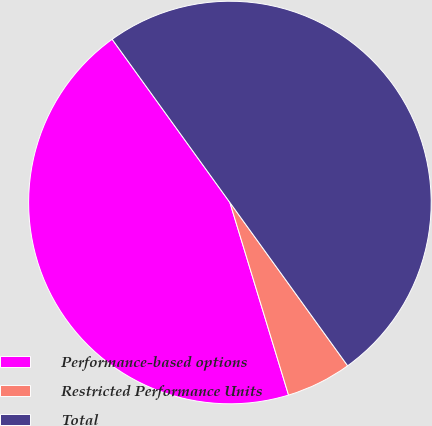Convert chart. <chart><loc_0><loc_0><loc_500><loc_500><pie_chart><fcel>Performance-based options<fcel>Restricted Performance Units<fcel>Total<nl><fcel>44.76%<fcel>5.24%<fcel>50.0%<nl></chart> 